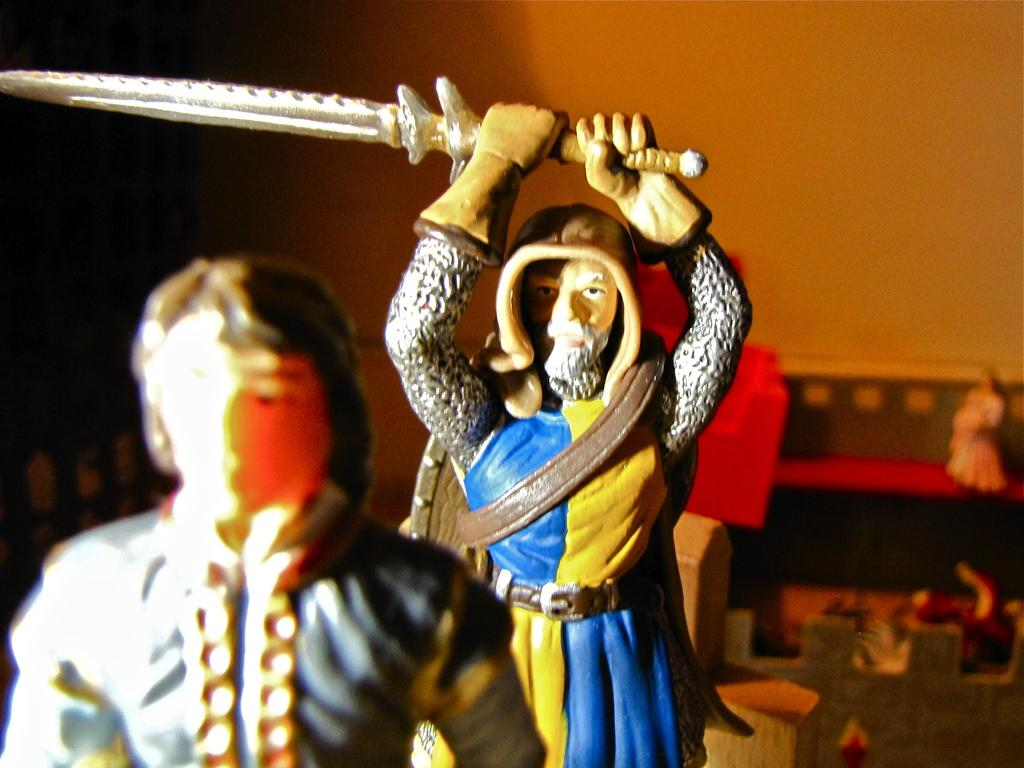What type of objects can be seen in the image? There are toys in the image. Can you describe the background of the image? The background of the image has a blurred view. What is visible in the image besides the toys? There is a wall visible in the image. How many objects can be seen in the image? There are objects in the image, but the exact number is not specified. What type of spy equipment can be seen in the image? There is no spy equipment present in the image; it features toys and a blurred background. How does the hope in the image move around? The image does not depict any concept of hope, and therefore it cannot move around. 